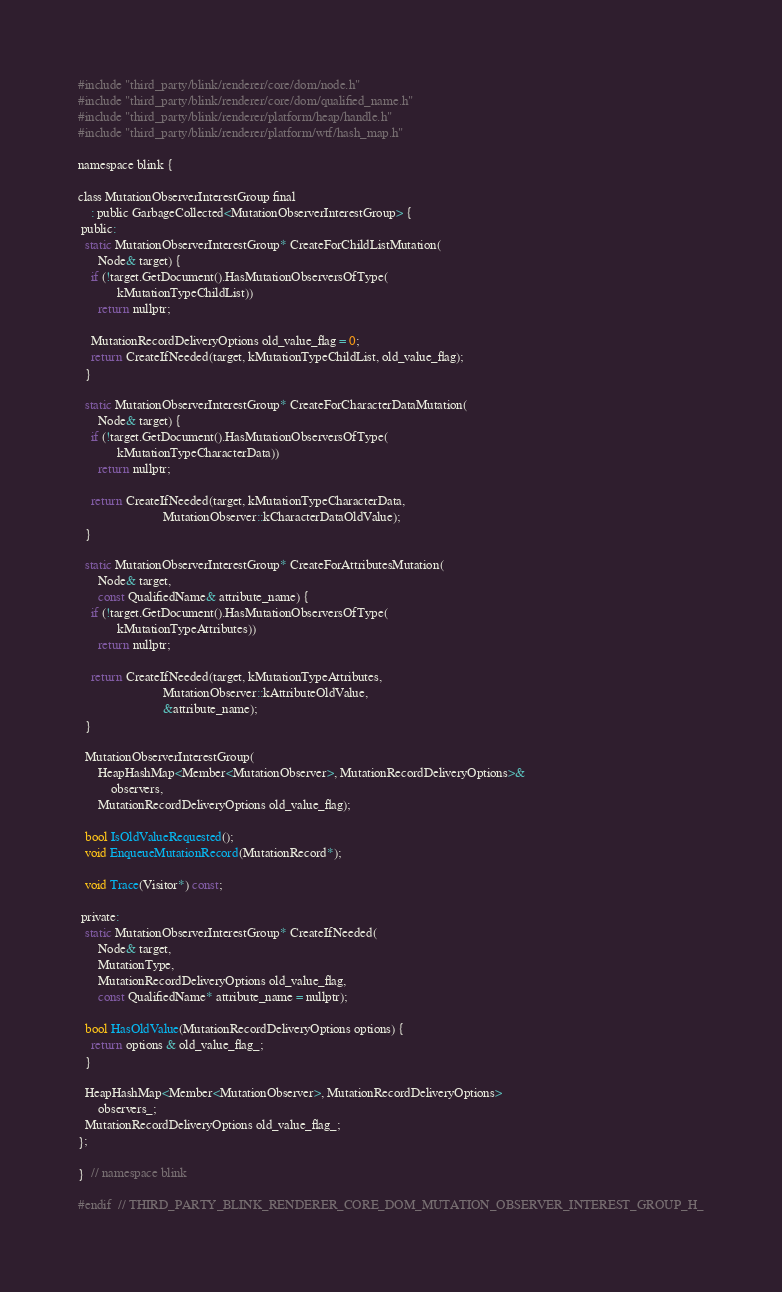Convert code to text. <code><loc_0><loc_0><loc_500><loc_500><_C_>#include "third_party/blink/renderer/core/dom/node.h"
#include "third_party/blink/renderer/core/dom/qualified_name.h"
#include "third_party/blink/renderer/platform/heap/handle.h"
#include "third_party/blink/renderer/platform/wtf/hash_map.h"

namespace blink {

class MutationObserverInterestGroup final
    : public GarbageCollected<MutationObserverInterestGroup> {
 public:
  static MutationObserverInterestGroup* CreateForChildListMutation(
      Node& target) {
    if (!target.GetDocument().HasMutationObserversOfType(
            kMutationTypeChildList))
      return nullptr;

    MutationRecordDeliveryOptions old_value_flag = 0;
    return CreateIfNeeded(target, kMutationTypeChildList, old_value_flag);
  }

  static MutationObserverInterestGroup* CreateForCharacterDataMutation(
      Node& target) {
    if (!target.GetDocument().HasMutationObserversOfType(
            kMutationTypeCharacterData))
      return nullptr;

    return CreateIfNeeded(target, kMutationTypeCharacterData,
                          MutationObserver::kCharacterDataOldValue);
  }

  static MutationObserverInterestGroup* CreateForAttributesMutation(
      Node& target,
      const QualifiedName& attribute_name) {
    if (!target.GetDocument().HasMutationObserversOfType(
            kMutationTypeAttributes))
      return nullptr;

    return CreateIfNeeded(target, kMutationTypeAttributes,
                          MutationObserver::kAttributeOldValue,
                          &attribute_name);
  }

  MutationObserverInterestGroup(
      HeapHashMap<Member<MutationObserver>, MutationRecordDeliveryOptions>&
          observers,
      MutationRecordDeliveryOptions old_value_flag);

  bool IsOldValueRequested();
  void EnqueueMutationRecord(MutationRecord*);

  void Trace(Visitor*) const;

 private:
  static MutationObserverInterestGroup* CreateIfNeeded(
      Node& target,
      MutationType,
      MutationRecordDeliveryOptions old_value_flag,
      const QualifiedName* attribute_name = nullptr);

  bool HasOldValue(MutationRecordDeliveryOptions options) {
    return options & old_value_flag_;
  }

  HeapHashMap<Member<MutationObserver>, MutationRecordDeliveryOptions>
      observers_;
  MutationRecordDeliveryOptions old_value_flag_;
};

}  // namespace blink

#endif  // THIRD_PARTY_BLINK_RENDERER_CORE_DOM_MUTATION_OBSERVER_INTEREST_GROUP_H_
</code> 